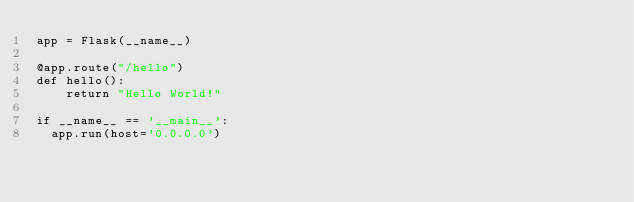<code> <loc_0><loc_0><loc_500><loc_500><_Python_>app = Flask(__name__)

@app.route("/hello")
def hello():
    return "Hello World!"

if __name__ == '__main__':
	app.run(host='0.0.0.0')</code> 